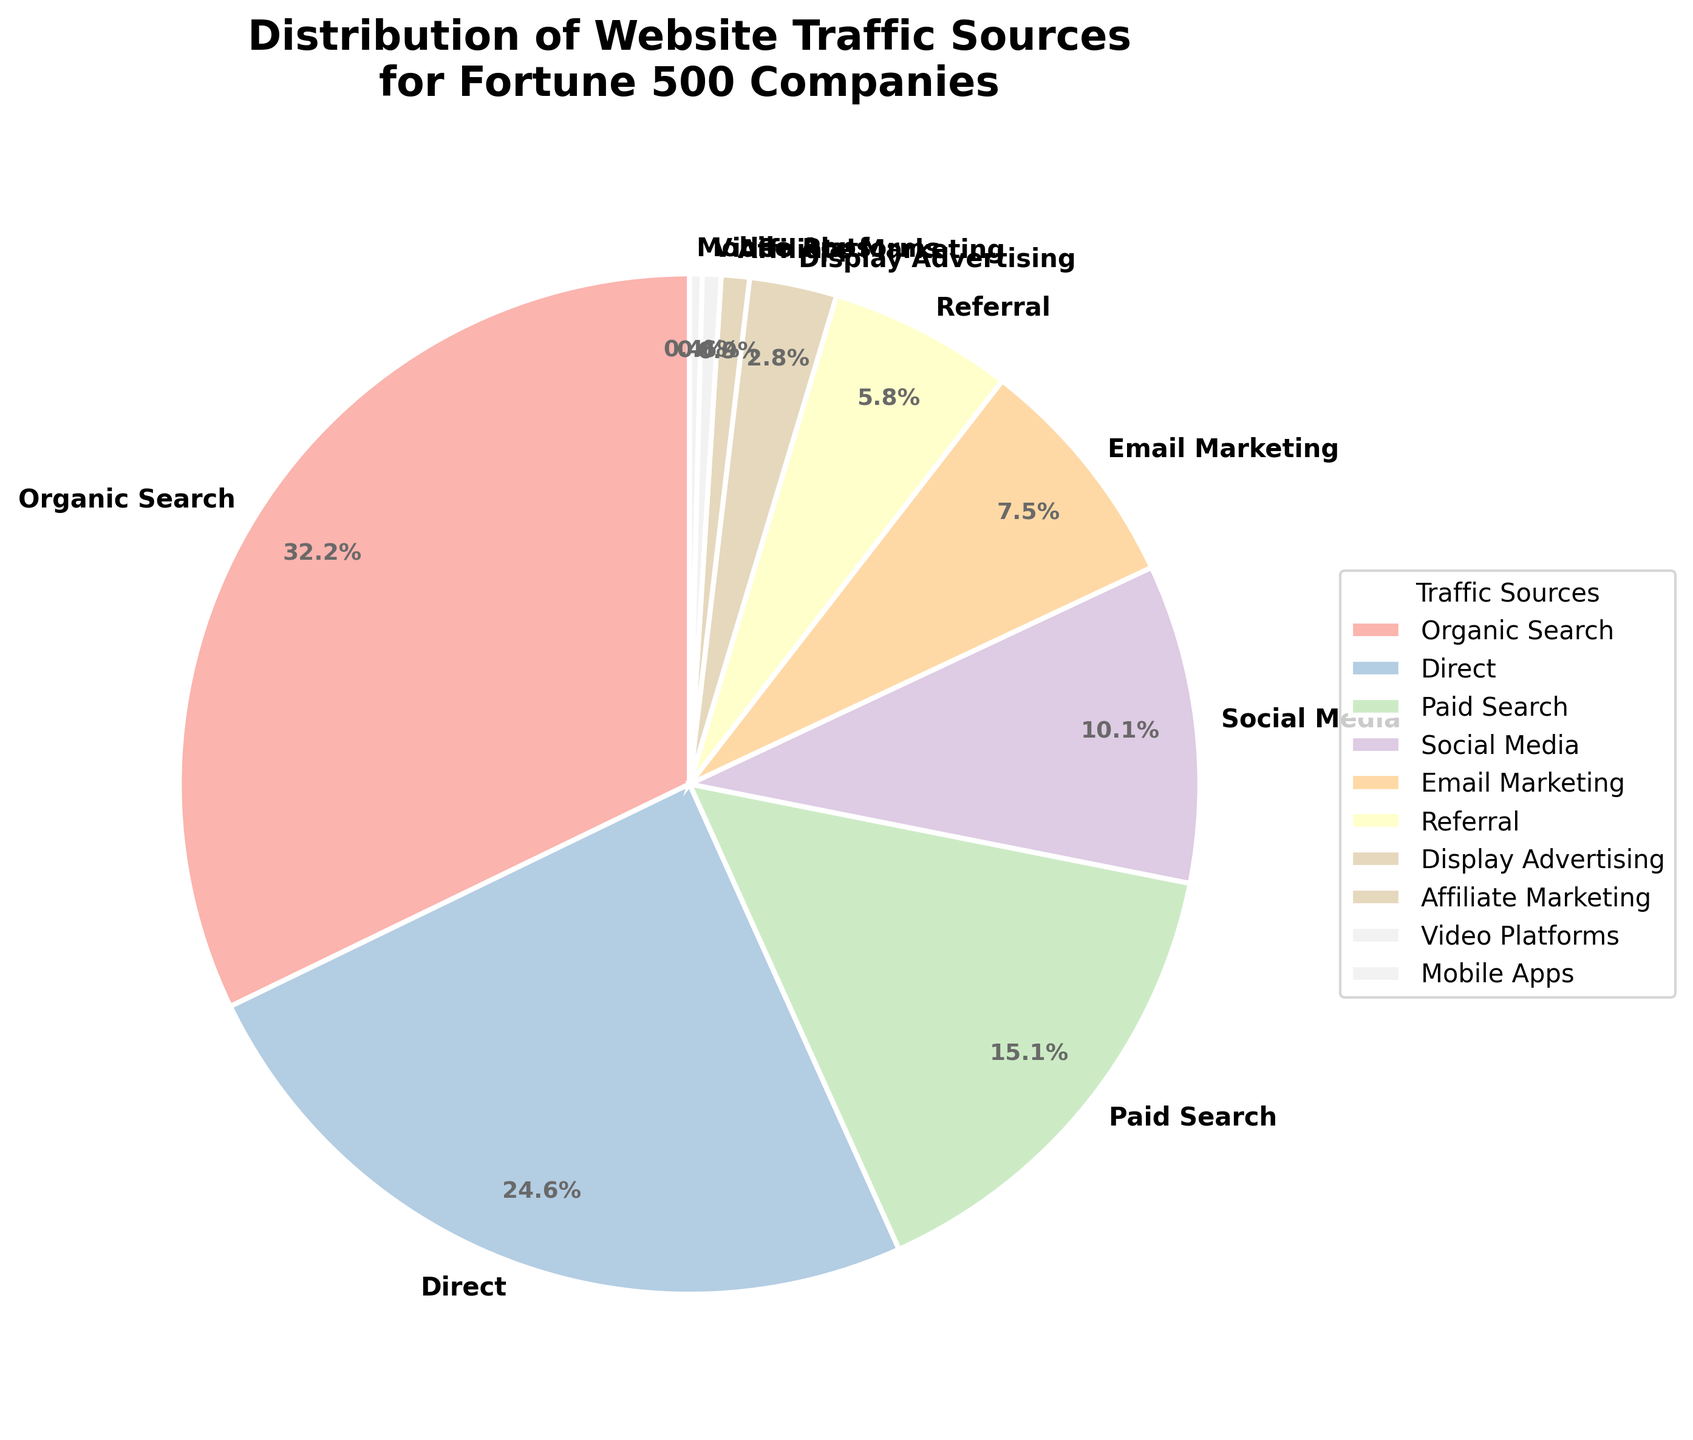What percentage of website traffic comes from Organic Search? The pie chart shows a slice labeled "Organic Search" with the percentage value indicated. Simply locate this labeled slice to find the percentage value.
Answer: 32.5% Which traffic source contributes the least to website traffic? In the pie chart, identify the smallest slice or refer to the labels and their corresponding percentage values. The traffic source with the smallest percentage value is the least contributor.
Answer: Mobile Apps How much more traffic does Organic Search generate compared to Direct traffic? Locate the percentage values for Organic Search (32.5%) and Direct (24.8%) in the chart. Subtract the percentage for Direct from the percentage for Organic Search: 32.5% - 24.8% = 7.7%.
Answer: 7.7% What are the combined contributions of Email Marketing and Social Media? Identify the percentage values for Email Marketing (7.6%) and Social Media (10.2%) on the chart, then sum these values: 7.6% + 10.2% = 17.8%.
Answer: 17.8% Which traffic source contributes more, Paid Search or Display Advertising, and by how much? Locate the percentage values for Paid Search (15.3%) and Display Advertising (2.8%). Subtract the smaller percentage from the larger percentage: 15.3% - 2.8% = 12.5%. Paid Search contributes more.
Answer: Paid Search by 12.5% Rank the top three traffic sources in descending order of their contributions. Review the percentage values for all traffic sources and order them from highest to lowest. The top three are Organic Search (32.5%), Direct (24.8%), and Paid Search (15.3%).
Answer: Organic Search, Direct, Paid Search What percentage of traffic comes from sources other than Organic Search and Direct? Calculate the combined percentage of Organic Search and Direct: 32.5% + 24.8% = 57.3%. Subtract this sum from 100% to find the percentage from other sources: 100% - 57.3% = 42.7%.
Answer: 42.7% Is the contribution of Social Media greater than Referral traffic? Compare the percentages presented in the chart for Social Media (10.2%) and Referral (5.9%). Since 10.2% is greater than 5.9%, Social Media contributes more.
Answer: Yes 